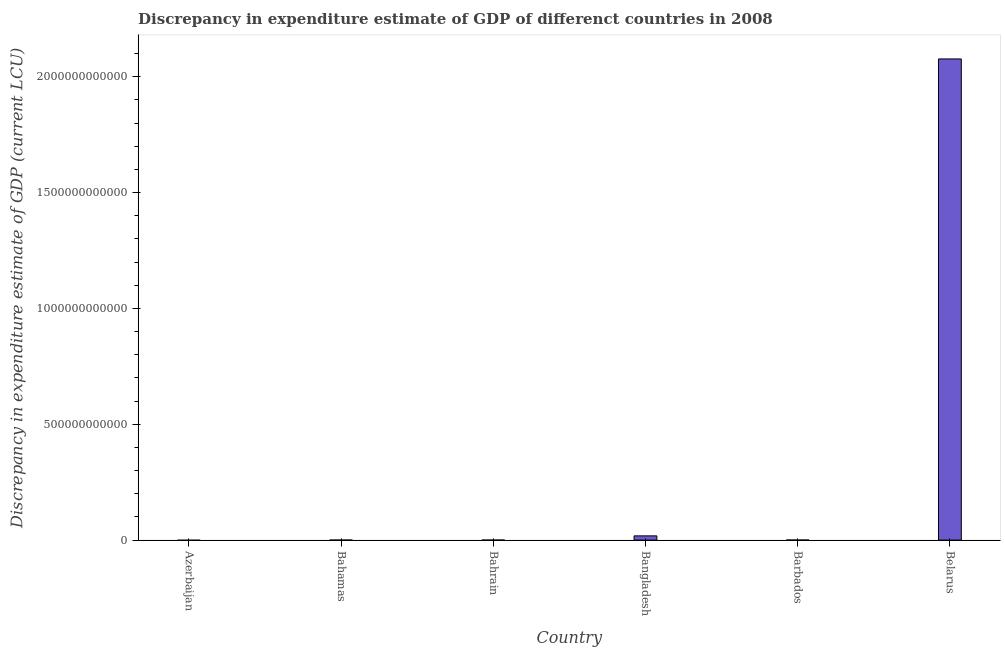Does the graph contain grids?
Give a very brief answer. No. What is the title of the graph?
Make the answer very short. Discrepancy in expenditure estimate of GDP of differenct countries in 2008. What is the label or title of the Y-axis?
Provide a succinct answer. Discrepancy in expenditure estimate of GDP (current LCU). What is the discrepancy in expenditure estimate of gdp in Bahrain?
Offer a terse response. 9.00e+04. Across all countries, what is the maximum discrepancy in expenditure estimate of gdp?
Ensure brevity in your answer.  2.08e+12. In which country was the discrepancy in expenditure estimate of gdp maximum?
Provide a short and direct response. Belarus. What is the sum of the discrepancy in expenditure estimate of gdp?
Offer a very short reply. 2.10e+12. What is the difference between the discrepancy in expenditure estimate of gdp in Bangladesh and Barbados?
Your response must be concise. 1.81e+1. What is the average discrepancy in expenditure estimate of gdp per country?
Make the answer very short. 3.49e+11. What is the median discrepancy in expenditure estimate of gdp?
Offer a very short reply. 6.75e+07. What is the ratio of the discrepancy in expenditure estimate of gdp in Bangladesh to that in Barbados?
Provide a succinct answer. 135.21. What is the difference between the highest and the second highest discrepancy in expenditure estimate of gdp?
Provide a short and direct response. 2.06e+12. What is the difference between the highest and the lowest discrepancy in expenditure estimate of gdp?
Provide a short and direct response. 2.08e+12. How many bars are there?
Give a very brief answer. 4. What is the difference between two consecutive major ticks on the Y-axis?
Your answer should be very brief. 5.00e+11. What is the Discrepancy in expenditure estimate of GDP (current LCU) in Bahamas?
Your answer should be compact. 0. What is the Discrepancy in expenditure estimate of GDP (current LCU) in Bahrain?
Offer a very short reply. 9.00e+04. What is the Discrepancy in expenditure estimate of GDP (current LCU) in Bangladesh?
Make the answer very short. 1.83e+1. What is the Discrepancy in expenditure estimate of GDP (current LCU) of Barbados?
Ensure brevity in your answer.  1.35e+08. What is the Discrepancy in expenditure estimate of GDP (current LCU) in Belarus?
Provide a succinct answer. 2.08e+12. What is the difference between the Discrepancy in expenditure estimate of GDP (current LCU) in Bahrain and Bangladesh?
Keep it short and to the point. -1.83e+1. What is the difference between the Discrepancy in expenditure estimate of GDP (current LCU) in Bahrain and Barbados?
Provide a short and direct response. -1.35e+08. What is the difference between the Discrepancy in expenditure estimate of GDP (current LCU) in Bahrain and Belarus?
Provide a succinct answer. -2.08e+12. What is the difference between the Discrepancy in expenditure estimate of GDP (current LCU) in Bangladesh and Barbados?
Provide a succinct answer. 1.81e+1. What is the difference between the Discrepancy in expenditure estimate of GDP (current LCU) in Bangladesh and Belarus?
Offer a very short reply. -2.06e+12. What is the difference between the Discrepancy in expenditure estimate of GDP (current LCU) in Barbados and Belarus?
Offer a very short reply. -2.08e+12. What is the ratio of the Discrepancy in expenditure estimate of GDP (current LCU) in Bahrain to that in Bangladesh?
Your answer should be very brief. 0. What is the ratio of the Discrepancy in expenditure estimate of GDP (current LCU) in Bahrain to that in Barbados?
Your answer should be very brief. 0. What is the ratio of the Discrepancy in expenditure estimate of GDP (current LCU) in Bangladesh to that in Barbados?
Ensure brevity in your answer.  135.21. What is the ratio of the Discrepancy in expenditure estimate of GDP (current LCU) in Bangladesh to that in Belarus?
Your response must be concise. 0.01. What is the ratio of the Discrepancy in expenditure estimate of GDP (current LCU) in Barbados to that in Belarus?
Your response must be concise. 0. 